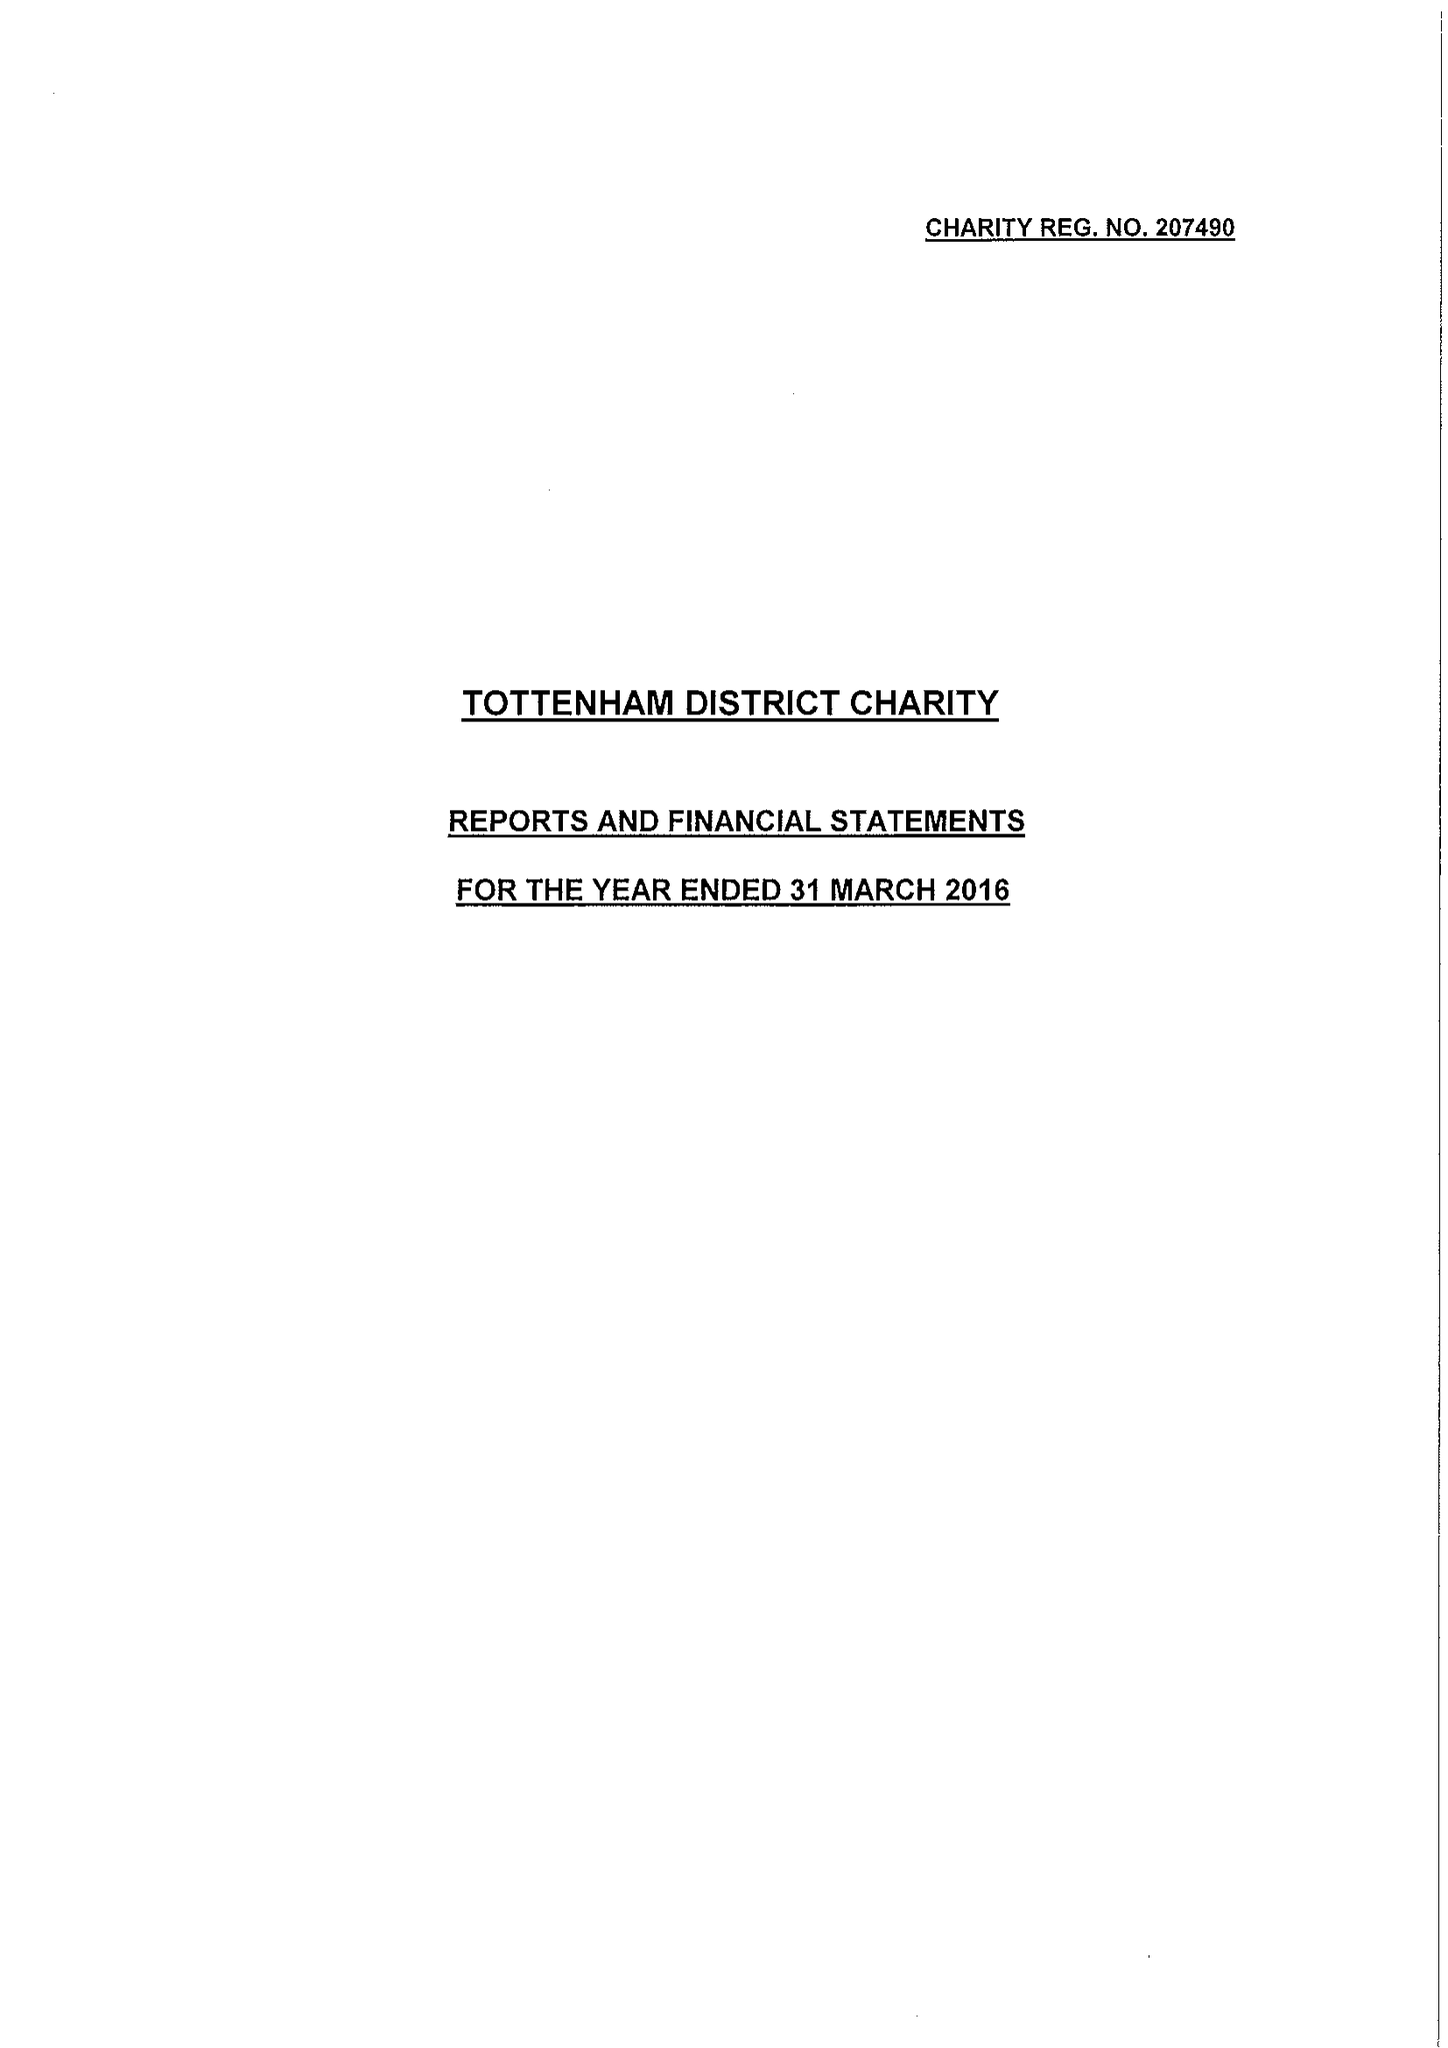What is the value for the address__street_line?
Answer the question using a single word or phrase. 225 HIGH ROAD 